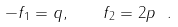Convert formula to latex. <formula><loc_0><loc_0><loc_500><loc_500>- f _ { 1 } = q , \quad f _ { 2 } = 2 p \ .</formula> 